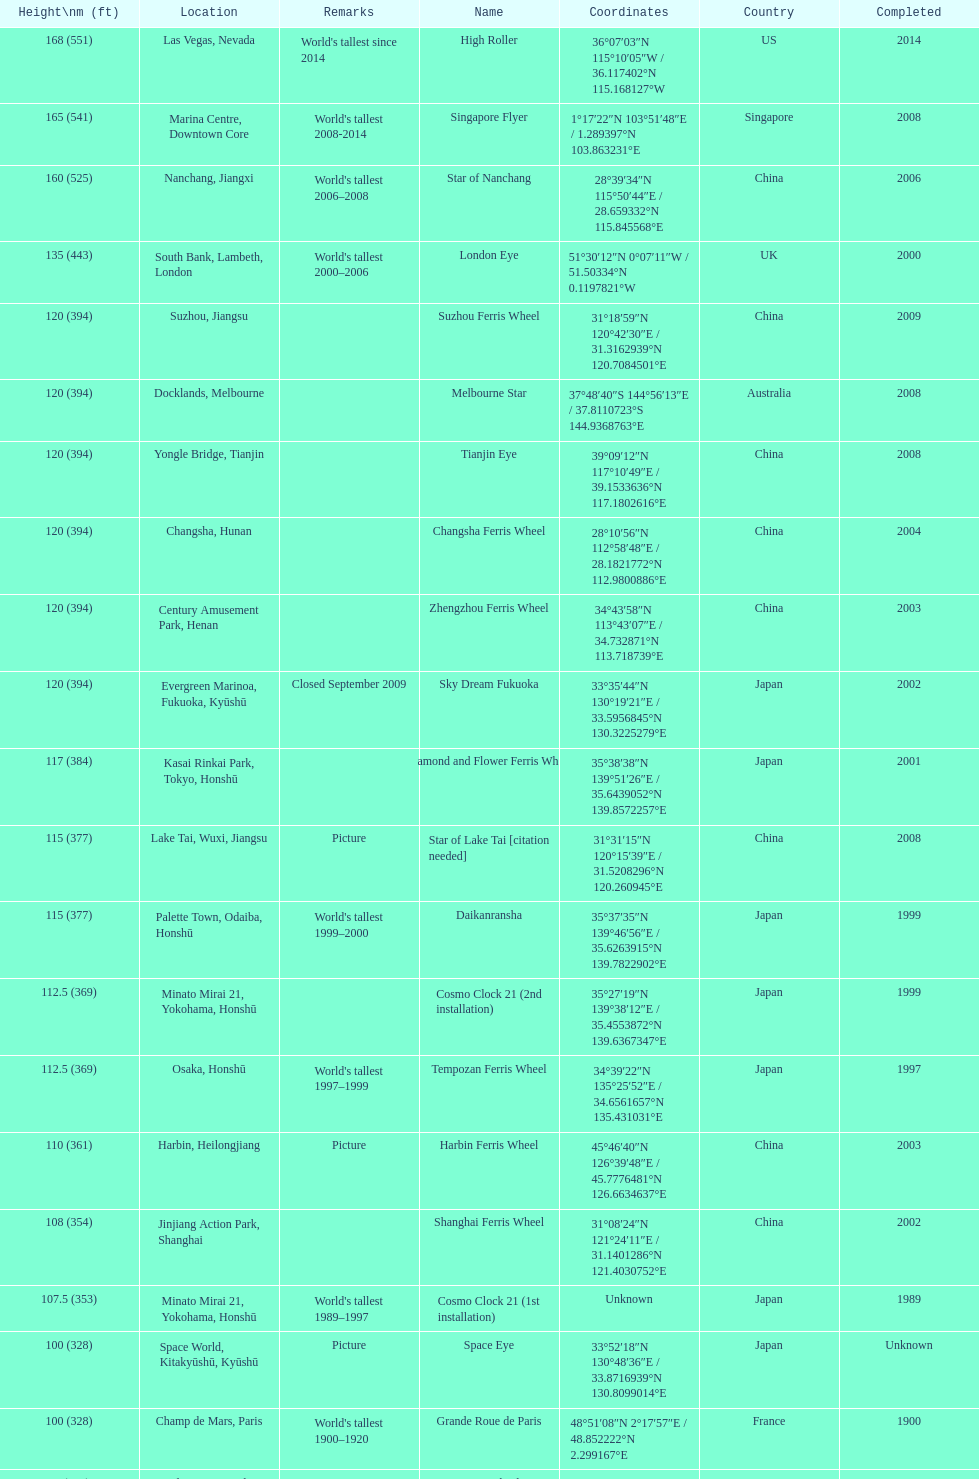Which of the following roller coasters is the oldest: star of lake tai, star of nanchang, melbourne star Star of Nanchang. 